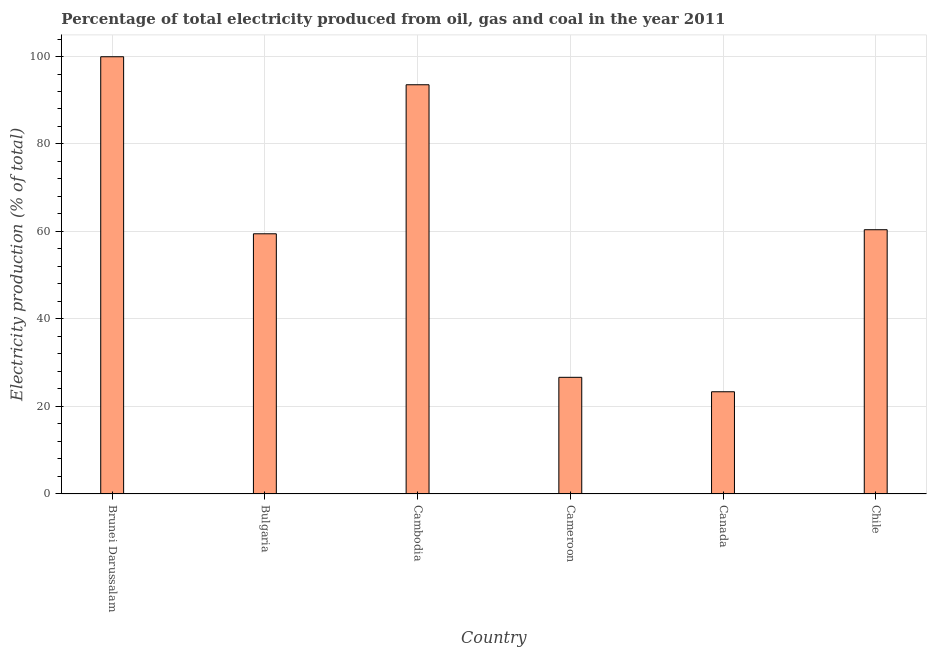Does the graph contain any zero values?
Provide a short and direct response. No. What is the title of the graph?
Your response must be concise. Percentage of total electricity produced from oil, gas and coal in the year 2011. What is the label or title of the Y-axis?
Your answer should be very brief. Electricity production (% of total). What is the electricity production in Cambodia?
Make the answer very short. 93.54. Across all countries, what is the maximum electricity production?
Give a very brief answer. 99.95. Across all countries, what is the minimum electricity production?
Provide a succinct answer. 23.37. In which country was the electricity production maximum?
Offer a very short reply. Brunei Darussalam. What is the sum of the electricity production?
Your answer should be very brief. 363.4. What is the difference between the electricity production in Canada and Chile?
Your response must be concise. -37.04. What is the average electricity production per country?
Ensure brevity in your answer.  60.57. What is the median electricity production?
Your response must be concise. 59.94. What is the ratio of the electricity production in Cameroon to that in Chile?
Your answer should be very brief. 0.44. What is the difference between the highest and the second highest electricity production?
Give a very brief answer. 6.4. Is the sum of the electricity production in Brunei Darussalam and Chile greater than the maximum electricity production across all countries?
Ensure brevity in your answer.  Yes. What is the difference between the highest and the lowest electricity production?
Your answer should be very brief. 76.58. In how many countries, is the electricity production greater than the average electricity production taken over all countries?
Make the answer very short. 2. How many countries are there in the graph?
Make the answer very short. 6. What is the difference between two consecutive major ticks on the Y-axis?
Ensure brevity in your answer.  20. Are the values on the major ticks of Y-axis written in scientific E-notation?
Your response must be concise. No. What is the Electricity production (% of total) of Brunei Darussalam?
Offer a very short reply. 99.95. What is the Electricity production (% of total) of Bulgaria?
Make the answer very short. 59.47. What is the Electricity production (% of total) in Cambodia?
Your answer should be compact. 93.54. What is the Electricity production (% of total) in Cameroon?
Provide a succinct answer. 26.67. What is the Electricity production (% of total) of Canada?
Make the answer very short. 23.37. What is the Electricity production (% of total) in Chile?
Offer a terse response. 60.4. What is the difference between the Electricity production (% of total) in Brunei Darussalam and Bulgaria?
Provide a succinct answer. 40.47. What is the difference between the Electricity production (% of total) in Brunei Darussalam and Cambodia?
Give a very brief answer. 6.4. What is the difference between the Electricity production (% of total) in Brunei Darussalam and Cameroon?
Keep it short and to the point. 73.28. What is the difference between the Electricity production (% of total) in Brunei Darussalam and Canada?
Provide a succinct answer. 76.58. What is the difference between the Electricity production (% of total) in Brunei Darussalam and Chile?
Your response must be concise. 39.54. What is the difference between the Electricity production (% of total) in Bulgaria and Cambodia?
Offer a terse response. -34.07. What is the difference between the Electricity production (% of total) in Bulgaria and Cameroon?
Offer a very short reply. 32.81. What is the difference between the Electricity production (% of total) in Bulgaria and Canada?
Your answer should be compact. 36.11. What is the difference between the Electricity production (% of total) in Bulgaria and Chile?
Provide a succinct answer. -0.93. What is the difference between the Electricity production (% of total) in Cambodia and Cameroon?
Offer a very short reply. 66.88. What is the difference between the Electricity production (% of total) in Cambodia and Canada?
Keep it short and to the point. 70.18. What is the difference between the Electricity production (% of total) in Cambodia and Chile?
Provide a short and direct response. 33.14. What is the difference between the Electricity production (% of total) in Cameroon and Canada?
Offer a very short reply. 3.3. What is the difference between the Electricity production (% of total) in Cameroon and Chile?
Offer a terse response. -33.74. What is the difference between the Electricity production (% of total) in Canada and Chile?
Ensure brevity in your answer.  -37.04. What is the ratio of the Electricity production (% of total) in Brunei Darussalam to that in Bulgaria?
Your answer should be compact. 1.68. What is the ratio of the Electricity production (% of total) in Brunei Darussalam to that in Cambodia?
Your answer should be compact. 1.07. What is the ratio of the Electricity production (% of total) in Brunei Darussalam to that in Cameroon?
Offer a very short reply. 3.75. What is the ratio of the Electricity production (% of total) in Brunei Darussalam to that in Canada?
Offer a terse response. 4.28. What is the ratio of the Electricity production (% of total) in Brunei Darussalam to that in Chile?
Give a very brief answer. 1.66. What is the ratio of the Electricity production (% of total) in Bulgaria to that in Cambodia?
Your response must be concise. 0.64. What is the ratio of the Electricity production (% of total) in Bulgaria to that in Cameroon?
Your response must be concise. 2.23. What is the ratio of the Electricity production (% of total) in Bulgaria to that in Canada?
Give a very brief answer. 2.54. What is the ratio of the Electricity production (% of total) in Bulgaria to that in Chile?
Offer a terse response. 0.98. What is the ratio of the Electricity production (% of total) in Cambodia to that in Cameroon?
Offer a terse response. 3.51. What is the ratio of the Electricity production (% of total) in Cambodia to that in Canada?
Provide a succinct answer. 4. What is the ratio of the Electricity production (% of total) in Cambodia to that in Chile?
Keep it short and to the point. 1.55. What is the ratio of the Electricity production (% of total) in Cameroon to that in Canada?
Your answer should be very brief. 1.14. What is the ratio of the Electricity production (% of total) in Cameroon to that in Chile?
Your answer should be compact. 0.44. What is the ratio of the Electricity production (% of total) in Canada to that in Chile?
Your response must be concise. 0.39. 